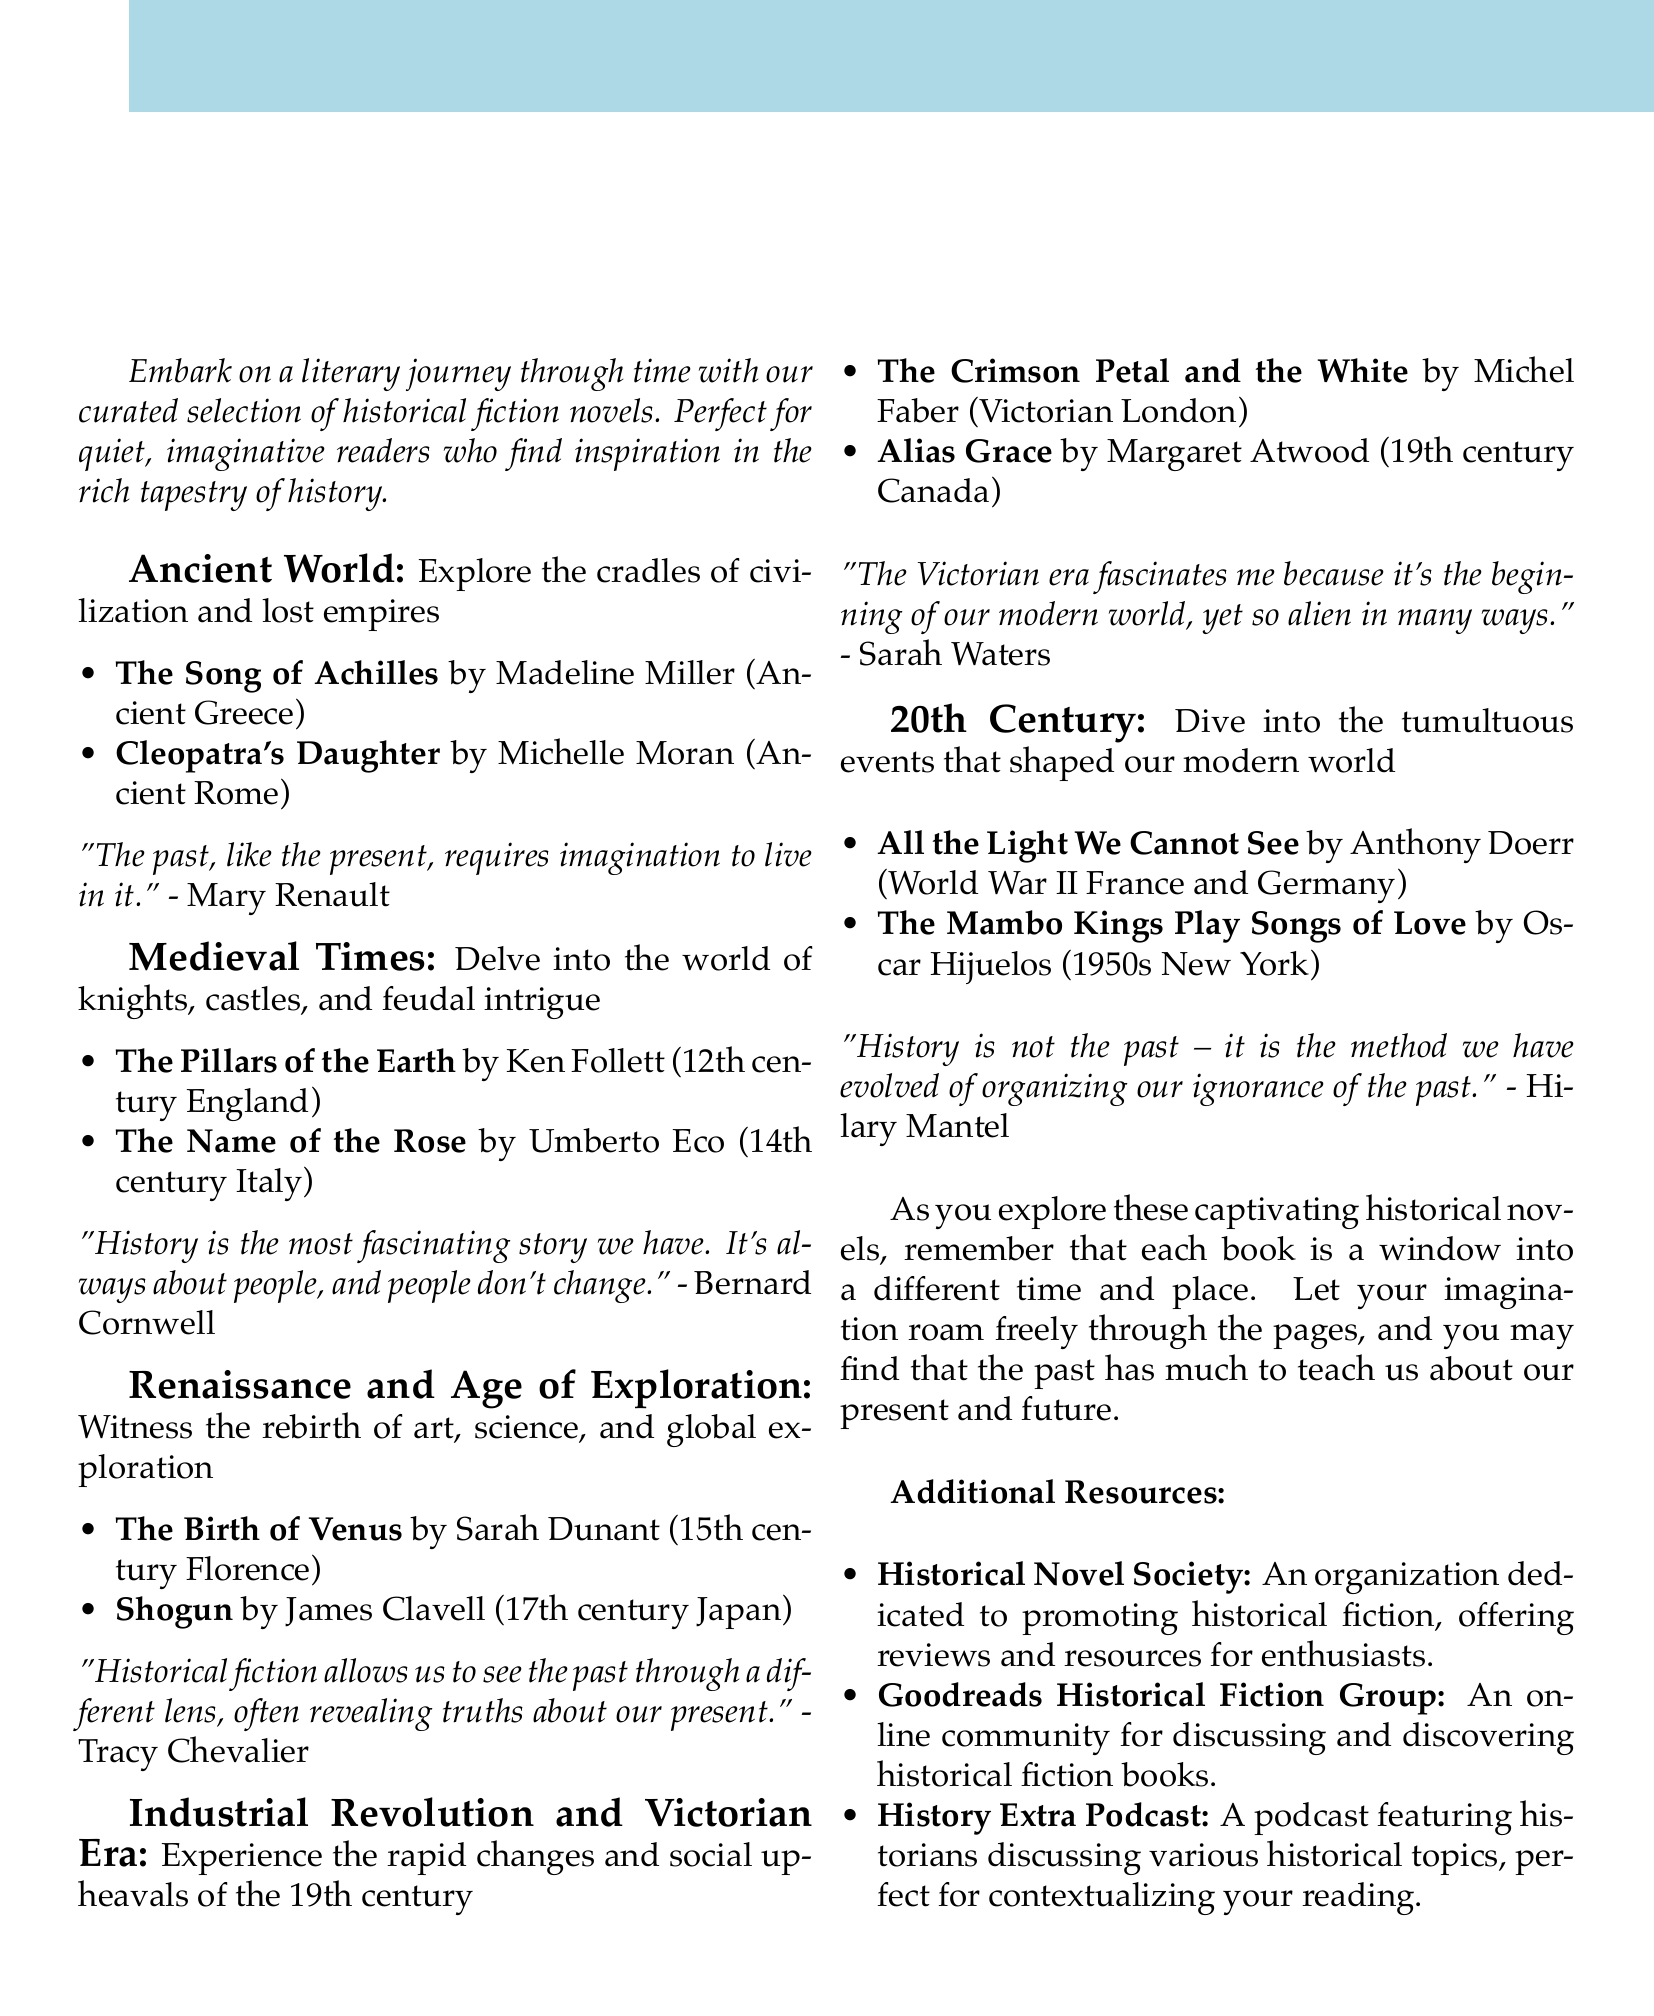what is the title of the brochure? The title of the brochure is presented at the beginning, which is "Time Traveler's Library: A Guide to Historical Fiction Across the Ages."
Answer: Time Traveler's Library: A Guide to Historical Fiction Across the Ages who is the author of "The Song of Achilles"? The document lists the author next to the book recommendations, identifying Madeline Miller as the author of "The Song of Achilles."
Answer: Madeline Miller what century does "Alias Grace" take place in? The setting for "Alias Grace" is provided under the book recommendations, indicating it takes place in the 19th century.
Answer: 19th century which era includes "All the Light We Cannot See"? Each era is categorized with specific book recommendations, with "All the Light We Cannot See" listed under the 20th Century.
Answer: 20th Century who provides the quote about historical fiction revealing truths about our present? The document attributes the quote discussing the perspective of historical fiction to Tracy Chevalier.
Answer: Tracy Chevalier what is the main focus of the Ancient World section? The Ancient World section describes what readers can expect, specifically "Explore the cradles of civilization and lost empires."
Answer: Explore the cradles of civilization and lost empires how many historical eras are highlighted in the document? The document contains sections for five distinct eras of historical fiction, which can be counted in the brochure.
Answer: Five what resource is dedicated to promoting historical fiction? The additional resources section includes one specifically aimed at promoting historical fiction, known as the Historical Novel Society.
Answer: Historical Novel Society which notable work is associated with Hilary Mantel? The interview with Hilary Mantel mentions her notable work, which is identified as the Wolf Hall trilogy.
Answer: Wolf Hall trilogy 